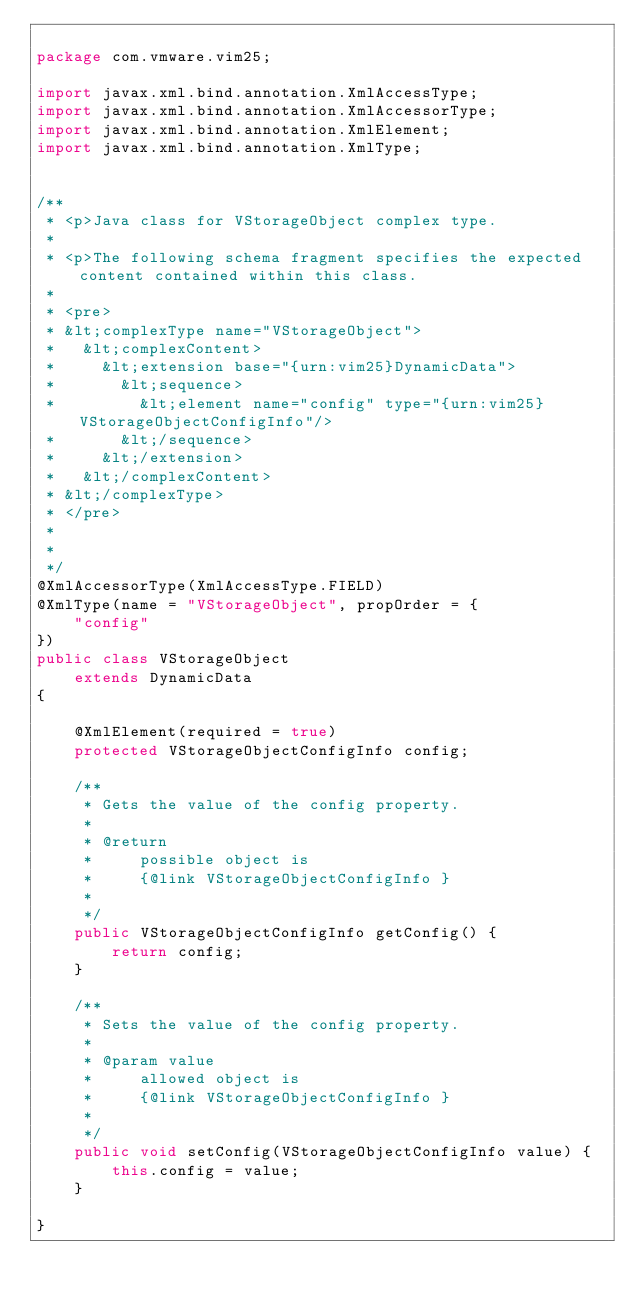Convert code to text. <code><loc_0><loc_0><loc_500><loc_500><_Java_>
package com.vmware.vim25;

import javax.xml.bind.annotation.XmlAccessType;
import javax.xml.bind.annotation.XmlAccessorType;
import javax.xml.bind.annotation.XmlElement;
import javax.xml.bind.annotation.XmlType;


/**
 * <p>Java class for VStorageObject complex type.
 * 
 * <p>The following schema fragment specifies the expected content contained within this class.
 * 
 * <pre>
 * &lt;complexType name="VStorageObject">
 *   &lt;complexContent>
 *     &lt;extension base="{urn:vim25}DynamicData">
 *       &lt;sequence>
 *         &lt;element name="config" type="{urn:vim25}VStorageObjectConfigInfo"/>
 *       &lt;/sequence>
 *     &lt;/extension>
 *   &lt;/complexContent>
 * &lt;/complexType>
 * </pre>
 * 
 * 
 */
@XmlAccessorType(XmlAccessType.FIELD)
@XmlType(name = "VStorageObject", propOrder = {
    "config"
})
public class VStorageObject
    extends DynamicData
{

    @XmlElement(required = true)
    protected VStorageObjectConfigInfo config;

    /**
     * Gets the value of the config property.
     * 
     * @return
     *     possible object is
     *     {@link VStorageObjectConfigInfo }
     *     
     */
    public VStorageObjectConfigInfo getConfig() {
        return config;
    }

    /**
     * Sets the value of the config property.
     * 
     * @param value
     *     allowed object is
     *     {@link VStorageObjectConfigInfo }
     *     
     */
    public void setConfig(VStorageObjectConfigInfo value) {
        this.config = value;
    }

}
</code> 